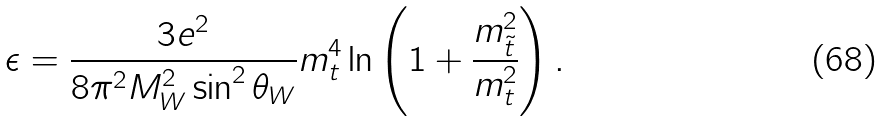Convert formula to latex. <formula><loc_0><loc_0><loc_500><loc_500>\epsilon = \frac { 3 e ^ { 2 } } { 8 \pi ^ { 2 } M _ { W } ^ { 2 } \sin ^ { 2 } \theta _ { W } } m _ { t } ^ { 4 } \ln \left ( 1 + \frac { { m } _ { \tilde { t } } ^ { 2 } } { m _ { t } ^ { 2 } } \right ) .</formula> 